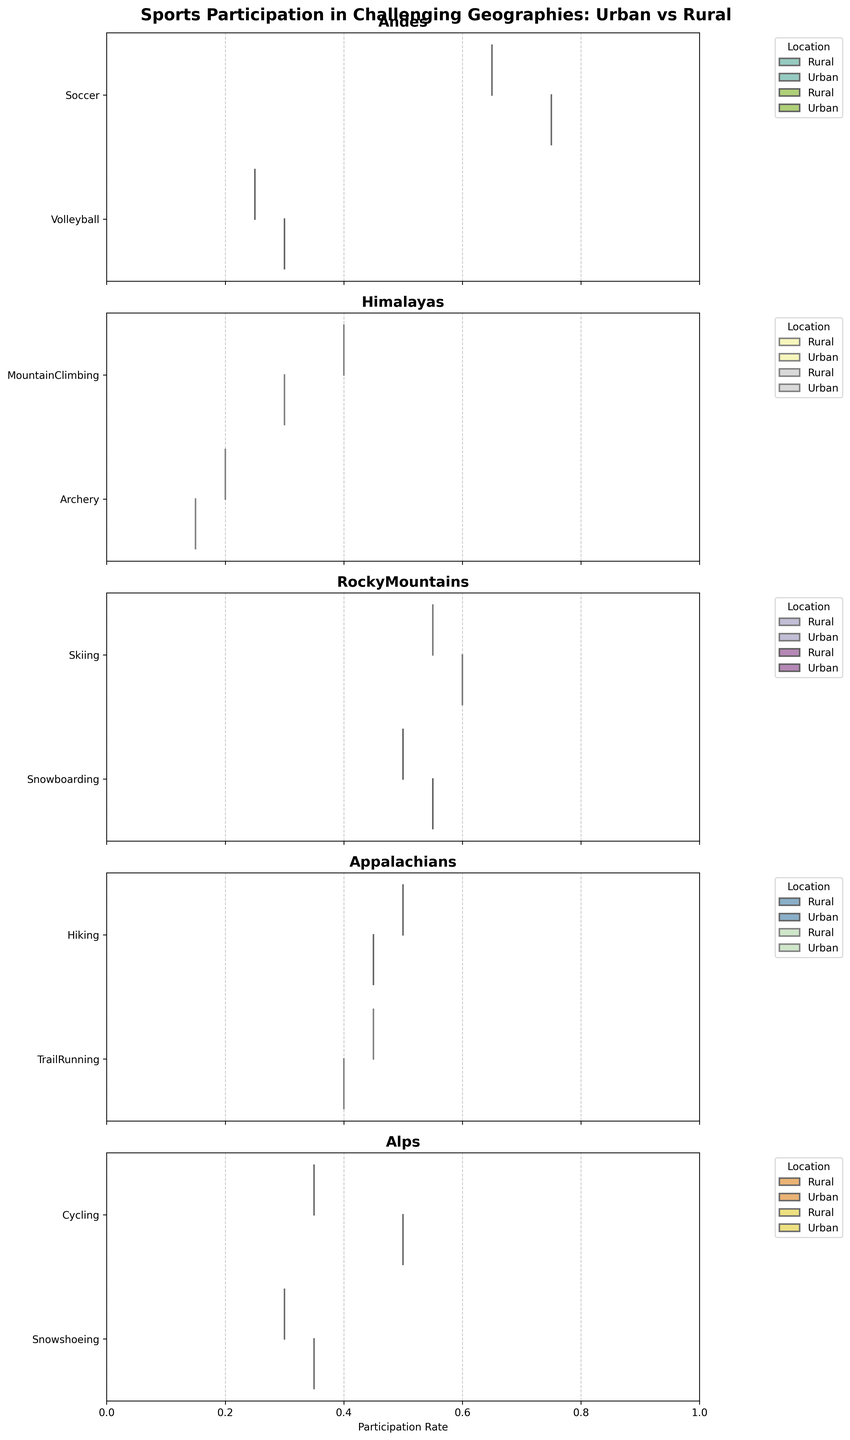What is the title of the figure? The title is usually found at the top of the figure and provides a summary of what the figure represents. In this case, it states the subject of the plot.
Answer: Sports Participation in Challenging Geographies: Urban vs Rural What is the participation rate difference between urban and rural regions for Soccer in the Andes? To determine the difference, look at the participation rates for rural (0.65) and urban (0.75) areas in the Andes for Soccer. Subtract the rural participation rate from the urban rate.
Answer: 0.10 In which region is Mountain Climbing more popular, urban or rural? By comparing the participation rates provided for the Himalayas—0.40 for rural and 0.30 for urban, it is clear which is higher.
Answer: Rural Which sport has the highest participation rate in the Rural Andes? Look at the participation rates of different sports in the Andes' rural regions and find the one with the highest rate. Here, Soccer has the highest rate of 0.65.
Answer: Soccer Compare the urban participation rate of Cycling in the Alps to the rural participation rate of Soccer in the Andes. Which is higher? The urban participation rate for Cycling in the Alps is 0.50, and the rural participation rate for Soccer in the Andes is 0.65. Compare these values to see which is higher.
Answer: Soccer in the Andes In which region do rural and urban participation rates for a particular sport differ the most? To find this, examine the participation rate differences between rural and urban locations for each sport in all regions. The largest difference is found in the Andes for Soccer with a 0.10 difference.
Answer: Andes for Soccer Which sport has more balanced participation rates between urban and rural locations in the Alps? Looking at the participation rates for the Alps, identify the sport where the rates between rural and urban are closest. Snowshoeing has a 0.30 rate in rural areas and a 0.35 rate in urban areas, showing the smallest difference.
Answer: Snowshoeing What is the median participation rate for Volleyball in the Andes? The median for Volleyball in the Andes requires ordering the participation rates (0.25 for rural and 0.30 for urban), then taking the middle value. Given two values, the median is the average of them.
Answer: 0.275 